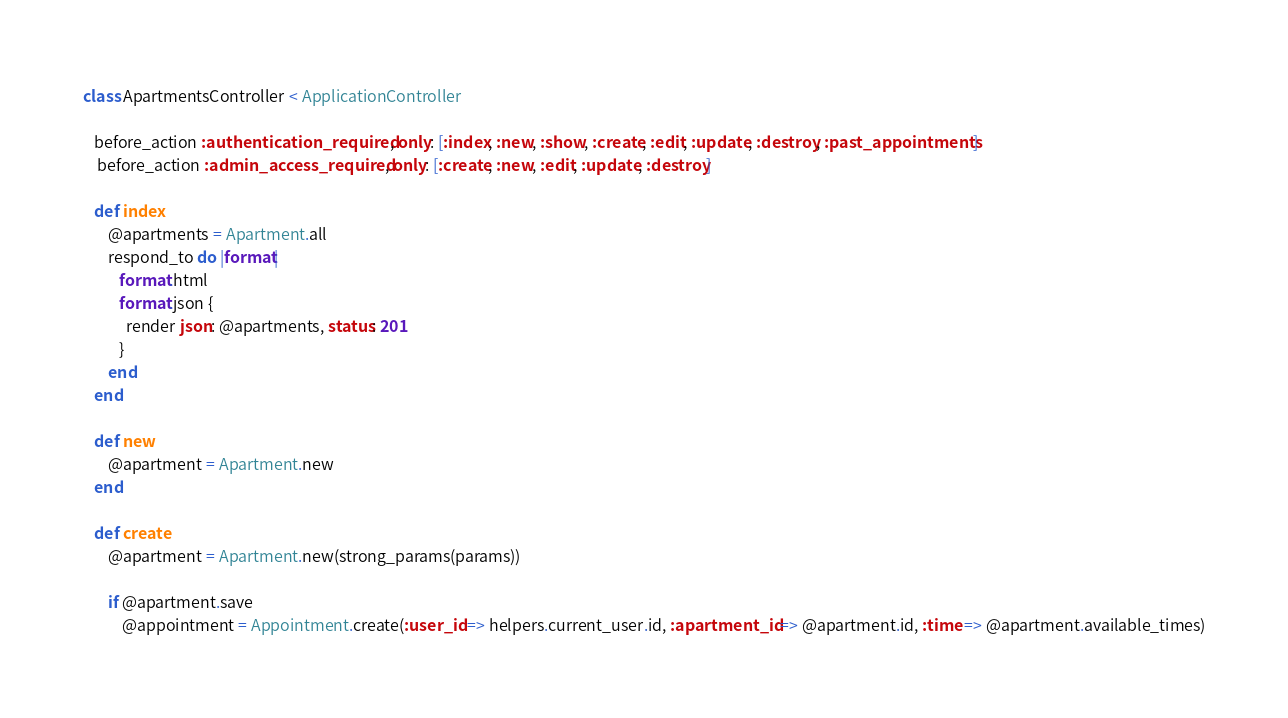<code> <loc_0><loc_0><loc_500><loc_500><_Ruby_>class ApartmentsController < ApplicationController

   before_action :authentication_required , only: [:index, :new, :show, :create, :edit, :update, :destroy, :past_appointments]
    before_action :admin_access_required, only: [:create, :new, :edit, :update, :destroy]

   def index
       @apartments = Apartment.all
       respond_to do |format|
          format.html
          format.json {
            render json: @apartments, status: 201
          }
       end
   end

   def new
       @apartment = Apartment.new
   end

   def create
       @apartment = Apartment.new(strong_params(params))

       if @apartment.save
           @appointment = Appointment.create(:user_id => helpers.current_user.id, :apartment_id => @apartment.id, :time => @apartment.available_times)</code> 